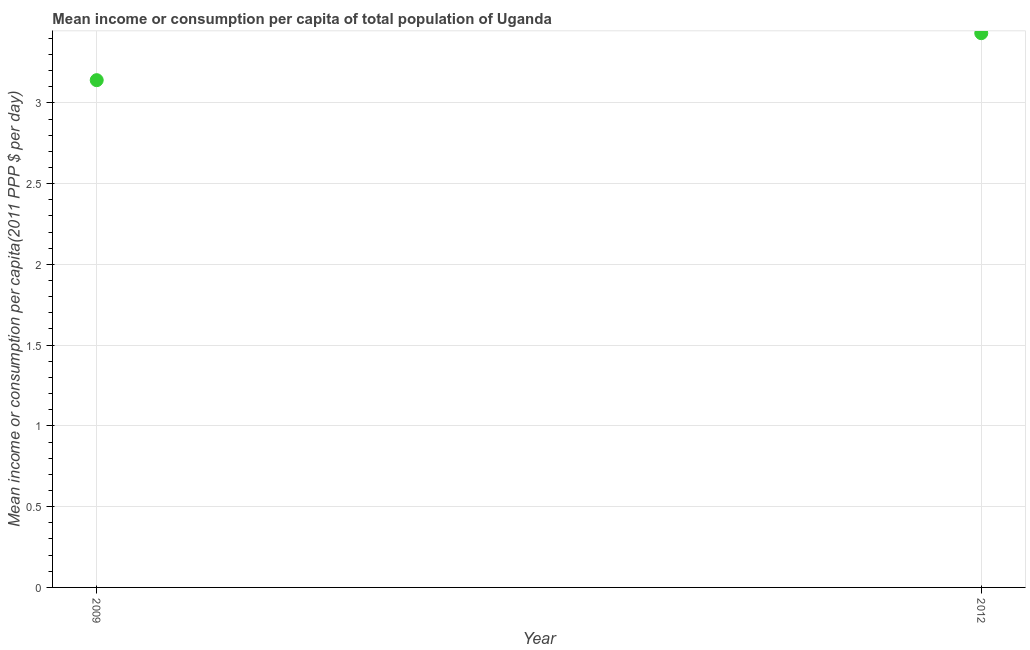What is the mean income or consumption in 2009?
Keep it short and to the point. 3.14. Across all years, what is the maximum mean income or consumption?
Ensure brevity in your answer.  3.43. Across all years, what is the minimum mean income or consumption?
Offer a very short reply. 3.14. What is the sum of the mean income or consumption?
Your response must be concise. 6.57. What is the difference between the mean income or consumption in 2009 and 2012?
Offer a terse response. -0.29. What is the average mean income or consumption per year?
Offer a very short reply. 3.29. What is the median mean income or consumption?
Provide a succinct answer. 3.29. Do a majority of the years between 2009 and 2012 (inclusive) have mean income or consumption greater than 3.2 $?
Keep it short and to the point. No. What is the ratio of the mean income or consumption in 2009 to that in 2012?
Keep it short and to the point. 0.92. Is the mean income or consumption in 2009 less than that in 2012?
Your answer should be very brief. Yes. Does the mean income or consumption monotonically increase over the years?
Ensure brevity in your answer.  Yes. What is the difference between two consecutive major ticks on the Y-axis?
Keep it short and to the point. 0.5. Are the values on the major ticks of Y-axis written in scientific E-notation?
Give a very brief answer. No. Does the graph contain any zero values?
Make the answer very short. No. Does the graph contain grids?
Offer a very short reply. Yes. What is the title of the graph?
Your response must be concise. Mean income or consumption per capita of total population of Uganda. What is the label or title of the X-axis?
Provide a succinct answer. Year. What is the label or title of the Y-axis?
Provide a short and direct response. Mean income or consumption per capita(2011 PPP $ per day). What is the Mean income or consumption per capita(2011 PPP $ per day) in 2009?
Keep it short and to the point. 3.14. What is the Mean income or consumption per capita(2011 PPP $ per day) in 2012?
Provide a succinct answer. 3.43. What is the difference between the Mean income or consumption per capita(2011 PPP $ per day) in 2009 and 2012?
Offer a very short reply. -0.29. What is the ratio of the Mean income or consumption per capita(2011 PPP $ per day) in 2009 to that in 2012?
Make the answer very short. 0.92. 